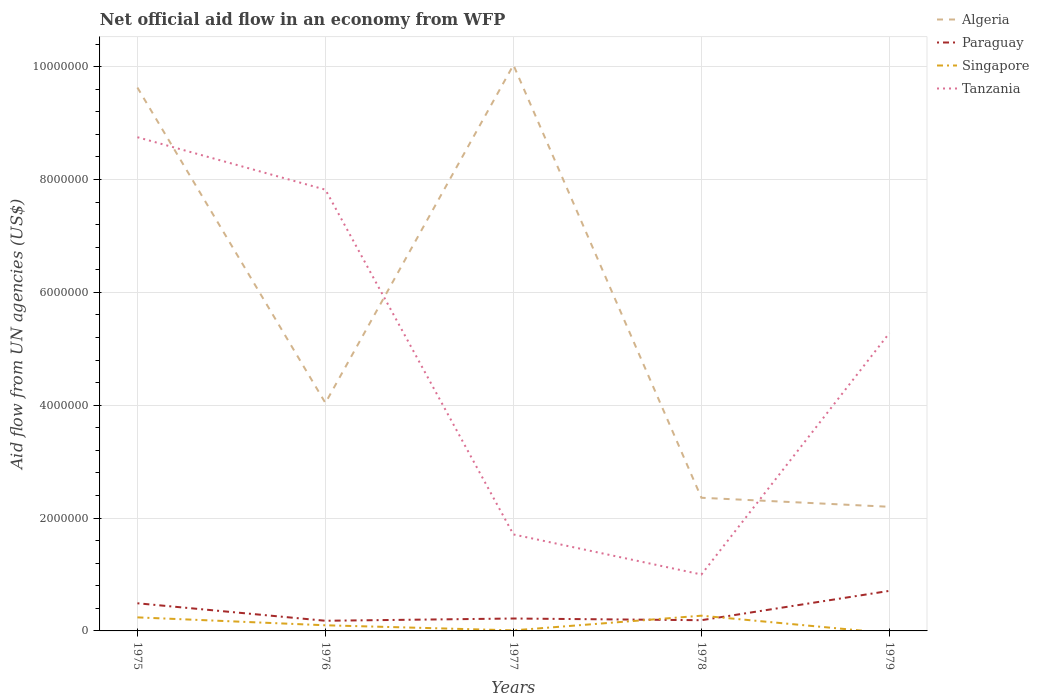How many different coloured lines are there?
Your response must be concise. 4. Does the line corresponding to Tanzania intersect with the line corresponding to Singapore?
Make the answer very short. No. Across all years, what is the maximum net official aid flow in Paraguay?
Offer a very short reply. 1.80e+05. What is the total net official aid flow in Singapore in the graph?
Give a very brief answer. 1.40e+05. What is the difference between the highest and the second highest net official aid flow in Tanzania?
Keep it short and to the point. 7.75e+06. How many years are there in the graph?
Offer a very short reply. 5. Are the values on the major ticks of Y-axis written in scientific E-notation?
Provide a succinct answer. No. Does the graph contain any zero values?
Provide a short and direct response. Yes. Does the graph contain grids?
Ensure brevity in your answer.  Yes. Where does the legend appear in the graph?
Provide a short and direct response. Top right. How many legend labels are there?
Offer a terse response. 4. What is the title of the graph?
Your answer should be very brief. Net official aid flow in an economy from WFP. What is the label or title of the X-axis?
Provide a short and direct response. Years. What is the label or title of the Y-axis?
Provide a succinct answer. Aid flow from UN agencies (US$). What is the Aid flow from UN agencies (US$) of Algeria in 1975?
Your answer should be very brief. 9.63e+06. What is the Aid flow from UN agencies (US$) in Paraguay in 1975?
Offer a very short reply. 4.90e+05. What is the Aid flow from UN agencies (US$) of Singapore in 1975?
Keep it short and to the point. 2.40e+05. What is the Aid flow from UN agencies (US$) in Tanzania in 1975?
Give a very brief answer. 8.75e+06. What is the Aid flow from UN agencies (US$) in Algeria in 1976?
Your answer should be very brief. 4.04e+06. What is the Aid flow from UN agencies (US$) in Paraguay in 1976?
Offer a very short reply. 1.80e+05. What is the Aid flow from UN agencies (US$) of Singapore in 1976?
Provide a succinct answer. 1.00e+05. What is the Aid flow from UN agencies (US$) of Tanzania in 1976?
Your answer should be compact. 7.82e+06. What is the Aid flow from UN agencies (US$) of Algeria in 1977?
Offer a very short reply. 1.00e+07. What is the Aid flow from UN agencies (US$) of Paraguay in 1977?
Provide a short and direct response. 2.20e+05. What is the Aid flow from UN agencies (US$) in Tanzania in 1977?
Keep it short and to the point. 1.71e+06. What is the Aid flow from UN agencies (US$) in Algeria in 1978?
Your answer should be compact. 2.36e+06. What is the Aid flow from UN agencies (US$) of Paraguay in 1978?
Ensure brevity in your answer.  1.90e+05. What is the Aid flow from UN agencies (US$) in Singapore in 1978?
Your response must be concise. 2.70e+05. What is the Aid flow from UN agencies (US$) of Algeria in 1979?
Your answer should be very brief. 2.20e+06. What is the Aid flow from UN agencies (US$) of Paraguay in 1979?
Your response must be concise. 7.10e+05. What is the Aid flow from UN agencies (US$) in Tanzania in 1979?
Keep it short and to the point. 5.28e+06. Across all years, what is the maximum Aid flow from UN agencies (US$) in Algeria?
Give a very brief answer. 1.00e+07. Across all years, what is the maximum Aid flow from UN agencies (US$) in Paraguay?
Provide a succinct answer. 7.10e+05. Across all years, what is the maximum Aid flow from UN agencies (US$) of Singapore?
Your answer should be compact. 2.70e+05. Across all years, what is the maximum Aid flow from UN agencies (US$) of Tanzania?
Give a very brief answer. 8.75e+06. Across all years, what is the minimum Aid flow from UN agencies (US$) in Algeria?
Keep it short and to the point. 2.20e+06. Across all years, what is the minimum Aid flow from UN agencies (US$) of Paraguay?
Offer a very short reply. 1.80e+05. What is the total Aid flow from UN agencies (US$) of Algeria in the graph?
Make the answer very short. 2.83e+07. What is the total Aid flow from UN agencies (US$) in Paraguay in the graph?
Make the answer very short. 1.79e+06. What is the total Aid flow from UN agencies (US$) of Singapore in the graph?
Keep it short and to the point. 6.20e+05. What is the total Aid flow from UN agencies (US$) of Tanzania in the graph?
Give a very brief answer. 2.46e+07. What is the difference between the Aid flow from UN agencies (US$) of Algeria in 1975 and that in 1976?
Keep it short and to the point. 5.59e+06. What is the difference between the Aid flow from UN agencies (US$) of Singapore in 1975 and that in 1976?
Keep it short and to the point. 1.40e+05. What is the difference between the Aid flow from UN agencies (US$) of Tanzania in 1975 and that in 1976?
Provide a succinct answer. 9.30e+05. What is the difference between the Aid flow from UN agencies (US$) of Algeria in 1975 and that in 1977?
Offer a terse response. -4.00e+05. What is the difference between the Aid flow from UN agencies (US$) in Paraguay in 1975 and that in 1977?
Your answer should be very brief. 2.70e+05. What is the difference between the Aid flow from UN agencies (US$) of Tanzania in 1975 and that in 1977?
Make the answer very short. 7.04e+06. What is the difference between the Aid flow from UN agencies (US$) of Algeria in 1975 and that in 1978?
Your answer should be compact. 7.27e+06. What is the difference between the Aid flow from UN agencies (US$) of Singapore in 1975 and that in 1978?
Give a very brief answer. -3.00e+04. What is the difference between the Aid flow from UN agencies (US$) in Tanzania in 1975 and that in 1978?
Your answer should be compact. 7.75e+06. What is the difference between the Aid flow from UN agencies (US$) of Algeria in 1975 and that in 1979?
Offer a terse response. 7.43e+06. What is the difference between the Aid flow from UN agencies (US$) of Paraguay in 1975 and that in 1979?
Your response must be concise. -2.20e+05. What is the difference between the Aid flow from UN agencies (US$) in Tanzania in 1975 and that in 1979?
Your answer should be compact. 3.47e+06. What is the difference between the Aid flow from UN agencies (US$) of Algeria in 1976 and that in 1977?
Keep it short and to the point. -5.99e+06. What is the difference between the Aid flow from UN agencies (US$) in Paraguay in 1976 and that in 1977?
Keep it short and to the point. -4.00e+04. What is the difference between the Aid flow from UN agencies (US$) of Tanzania in 1976 and that in 1977?
Keep it short and to the point. 6.11e+06. What is the difference between the Aid flow from UN agencies (US$) in Algeria in 1976 and that in 1978?
Offer a terse response. 1.68e+06. What is the difference between the Aid flow from UN agencies (US$) in Paraguay in 1976 and that in 1978?
Give a very brief answer. -10000. What is the difference between the Aid flow from UN agencies (US$) in Tanzania in 1976 and that in 1978?
Your answer should be compact. 6.82e+06. What is the difference between the Aid flow from UN agencies (US$) in Algeria in 1976 and that in 1979?
Your answer should be compact. 1.84e+06. What is the difference between the Aid flow from UN agencies (US$) of Paraguay in 1976 and that in 1979?
Provide a succinct answer. -5.30e+05. What is the difference between the Aid flow from UN agencies (US$) of Tanzania in 1976 and that in 1979?
Offer a very short reply. 2.54e+06. What is the difference between the Aid flow from UN agencies (US$) of Algeria in 1977 and that in 1978?
Offer a terse response. 7.67e+06. What is the difference between the Aid flow from UN agencies (US$) in Paraguay in 1977 and that in 1978?
Offer a very short reply. 3.00e+04. What is the difference between the Aid flow from UN agencies (US$) of Tanzania in 1977 and that in 1978?
Offer a terse response. 7.10e+05. What is the difference between the Aid flow from UN agencies (US$) of Algeria in 1977 and that in 1979?
Your answer should be compact. 7.83e+06. What is the difference between the Aid flow from UN agencies (US$) of Paraguay in 1977 and that in 1979?
Your answer should be compact. -4.90e+05. What is the difference between the Aid flow from UN agencies (US$) in Tanzania in 1977 and that in 1979?
Provide a short and direct response. -3.57e+06. What is the difference between the Aid flow from UN agencies (US$) in Paraguay in 1978 and that in 1979?
Give a very brief answer. -5.20e+05. What is the difference between the Aid flow from UN agencies (US$) in Tanzania in 1978 and that in 1979?
Offer a very short reply. -4.28e+06. What is the difference between the Aid flow from UN agencies (US$) in Algeria in 1975 and the Aid flow from UN agencies (US$) in Paraguay in 1976?
Give a very brief answer. 9.45e+06. What is the difference between the Aid flow from UN agencies (US$) in Algeria in 1975 and the Aid flow from UN agencies (US$) in Singapore in 1976?
Keep it short and to the point. 9.53e+06. What is the difference between the Aid flow from UN agencies (US$) in Algeria in 1975 and the Aid flow from UN agencies (US$) in Tanzania in 1976?
Offer a very short reply. 1.81e+06. What is the difference between the Aid flow from UN agencies (US$) in Paraguay in 1975 and the Aid flow from UN agencies (US$) in Singapore in 1976?
Your answer should be compact. 3.90e+05. What is the difference between the Aid flow from UN agencies (US$) of Paraguay in 1975 and the Aid flow from UN agencies (US$) of Tanzania in 1976?
Ensure brevity in your answer.  -7.33e+06. What is the difference between the Aid flow from UN agencies (US$) of Singapore in 1975 and the Aid flow from UN agencies (US$) of Tanzania in 1976?
Your answer should be very brief. -7.58e+06. What is the difference between the Aid flow from UN agencies (US$) of Algeria in 1975 and the Aid flow from UN agencies (US$) of Paraguay in 1977?
Ensure brevity in your answer.  9.41e+06. What is the difference between the Aid flow from UN agencies (US$) of Algeria in 1975 and the Aid flow from UN agencies (US$) of Singapore in 1977?
Keep it short and to the point. 9.62e+06. What is the difference between the Aid flow from UN agencies (US$) of Algeria in 1975 and the Aid flow from UN agencies (US$) of Tanzania in 1977?
Make the answer very short. 7.92e+06. What is the difference between the Aid flow from UN agencies (US$) in Paraguay in 1975 and the Aid flow from UN agencies (US$) in Singapore in 1977?
Your response must be concise. 4.80e+05. What is the difference between the Aid flow from UN agencies (US$) in Paraguay in 1975 and the Aid flow from UN agencies (US$) in Tanzania in 1977?
Provide a succinct answer. -1.22e+06. What is the difference between the Aid flow from UN agencies (US$) of Singapore in 1975 and the Aid flow from UN agencies (US$) of Tanzania in 1977?
Provide a succinct answer. -1.47e+06. What is the difference between the Aid flow from UN agencies (US$) of Algeria in 1975 and the Aid flow from UN agencies (US$) of Paraguay in 1978?
Give a very brief answer. 9.44e+06. What is the difference between the Aid flow from UN agencies (US$) in Algeria in 1975 and the Aid flow from UN agencies (US$) in Singapore in 1978?
Your answer should be compact. 9.36e+06. What is the difference between the Aid flow from UN agencies (US$) in Algeria in 1975 and the Aid flow from UN agencies (US$) in Tanzania in 1978?
Your response must be concise. 8.63e+06. What is the difference between the Aid flow from UN agencies (US$) of Paraguay in 1975 and the Aid flow from UN agencies (US$) of Singapore in 1978?
Offer a terse response. 2.20e+05. What is the difference between the Aid flow from UN agencies (US$) in Paraguay in 1975 and the Aid flow from UN agencies (US$) in Tanzania in 1978?
Provide a succinct answer. -5.10e+05. What is the difference between the Aid flow from UN agencies (US$) of Singapore in 1975 and the Aid flow from UN agencies (US$) of Tanzania in 1978?
Provide a short and direct response. -7.60e+05. What is the difference between the Aid flow from UN agencies (US$) of Algeria in 1975 and the Aid flow from UN agencies (US$) of Paraguay in 1979?
Your answer should be very brief. 8.92e+06. What is the difference between the Aid flow from UN agencies (US$) of Algeria in 1975 and the Aid flow from UN agencies (US$) of Tanzania in 1979?
Give a very brief answer. 4.35e+06. What is the difference between the Aid flow from UN agencies (US$) of Paraguay in 1975 and the Aid flow from UN agencies (US$) of Tanzania in 1979?
Your response must be concise. -4.79e+06. What is the difference between the Aid flow from UN agencies (US$) in Singapore in 1975 and the Aid flow from UN agencies (US$) in Tanzania in 1979?
Ensure brevity in your answer.  -5.04e+06. What is the difference between the Aid flow from UN agencies (US$) in Algeria in 1976 and the Aid flow from UN agencies (US$) in Paraguay in 1977?
Provide a succinct answer. 3.82e+06. What is the difference between the Aid flow from UN agencies (US$) in Algeria in 1976 and the Aid flow from UN agencies (US$) in Singapore in 1977?
Your answer should be very brief. 4.03e+06. What is the difference between the Aid flow from UN agencies (US$) in Algeria in 1976 and the Aid flow from UN agencies (US$) in Tanzania in 1977?
Make the answer very short. 2.33e+06. What is the difference between the Aid flow from UN agencies (US$) in Paraguay in 1976 and the Aid flow from UN agencies (US$) in Tanzania in 1977?
Your answer should be compact. -1.53e+06. What is the difference between the Aid flow from UN agencies (US$) of Singapore in 1976 and the Aid flow from UN agencies (US$) of Tanzania in 1977?
Provide a short and direct response. -1.61e+06. What is the difference between the Aid flow from UN agencies (US$) in Algeria in 1976 and the Aid flow from UN agencies (US$) in Paraguay in 1978?
Keep it short and to the point. 3.85e+06. What is the difference between the Aid flow from UN agencies (US$) of Algeria in 1976 and the Aid flow from UN agencies (US$) of Singapore in 1978?
Your response must be concise. 3.77e+06. What is the difference between the Aid flow from UN agencies (US$) of Algeria in 1976 and the Aid flow from UN agencies (US$) of Tanzania in 1978?
Keep it short and to the point. 3.04e+06. What is the difference between the Aid flow from UN agencies (US$) of Paraguay in 1976 and the Aid flow from UN agencies (US$) of Singapore in 1978?
Offer a terse response. -9.00e+04. What is the difference between the Aid flow from UN agencies (US$) of Paraguay in 1976 and the Aid flow from UN agencies (US$) of Tanzania in 1978?
Offer a very short reply. -8.20e+05. What is the difference between the Aid flow from UN agencies (US$) of Singapore in 1976 and the Aid flow from UN agencies (US$) of Tanzania in 1978?
Your answer should be very brief. -9.00e+05. What is the difference between the Aid flow from UN agencies (US$) in Algeria in 1976 and the Aid flow from UN agencies (US$) in Paraguay in 1979?
Your answer should be very brief. 3.33e+06. What is the difference between the Aid flow from UN agencies (US$) in Algeria in 1976 and the Aid flow from UN agencies (US$) in Tanzania in 1979?
Provide a short and direct response. -1.24e+06. What is the difference between the Aid flow from UN agencies (US$) in Paraguay in 1976 and the Aid flow from UN agencies (US$) in Tanzania in 1979?
Give a very brief answer. -5.10e+06. What is the difference between the Aid flow from UN agencies (US$) of Singapore in 1976 and the Aid flow from UN agencies (US$) of Tanzania in 1979?
Offer a terse response. -5.18e+06. What is the difference between the Aid flow from UN agencies (US$) in Algeria in 1977 and the Aid flow from UN agencies (US$) in Paraguay in 1978?
Offer a very short reply. 9.84e+06. What is the difference between the Aid flow from UN agencies (US$) in Algeria in 1977 and the Aid flow from UN agencies (US$) in Singapore in 1978?
Your answer should be very brief. 9.76e+06. What is the difference between the Aid flow from UN agencies (US$) in Algeria in 1977 and the Aid flow from UN agencies (US$) in Tanzania in 1978?
Give a very brief answer. 9.03e+06. What is the difference between the Aid flow from UN agencies (US$) in Paraguay in 1977 and the Aid flow from UN agencies (US$) in Singapore in 1978?
Your response must be concise. -5.00e+04. What is the difference between the Aid flow from UN agencies (US$) of Paraguay in 1977 and the Aid flow from UN agencies (US$) of Tanzania in 1978?
Your answer should be compact. -7.80e+05. What is the difference between the Aid flow from UN agencies (US$) of Singapore in 1977 and the Aid flow from UN agencies (US$) of Tanzania in 1978?
Provide a short and direct response. -9.90e+05. What is the difference between the Aid flow from UN agencies (US$) in Algeria in 1977 and the Aid flow from UN agencies (US$) in Paraguay in 1979?
Give a very brief answer. 9.32e+06. What is the difference between the Aid flow from UN agencies (US$) of Algeria in 1977 and the Aid flow from UN agencies (US$) of Tanzania in 1979?
Keep it short and to the point. 4.75e+06. What is the difference between the Aid flow from UN agencies (US$) of Paraguay in 1977 and the Aid flow from UN agencies (US$) of Tanzania in 1979?
Provide a short and direct response. -5.06e+06. What is the difference between the Aid flow from UN agencies (US$) in Singapore in 1977 and the Aid flow from UN agencies (US$) in Tanzania in 1979?
Ensure brevity in your answer.  -5.27e+06. What is the difference between the Aid flow from UN agencies (US$) of Algeria in 1978 and the Aid flow from UN agencies (US$) of Paraguay in 1979?
Offer a very short reply. 1.65e+06. What is the difference between the Aid flow from UN agencies (US$) in Algeria in 1978 and the Aid flow from UN agencies (US$) in Tanzania in 1979?
Ensure brevity in your answer.  -2.92e+06. What is the difference between the Aid flow from UN agencies (US$) of Paraguay in 1978 and the Aid flow from UN agencies (US$) of Tanzania in 1979?
Offer a terse response. -5.09e+06. What is the difference between the Aid flow from UN agencies (US$) in Singapore in 1978 and the Aid flow from UN agencies (US$) in Tanzania in 1979?
Offer a terse response. -5.01e+06. What is the average Aid flow from UN agencies (US$) of Algeria per year?
Ensure brevity in your answer.  5.65e+06. What is the average Aid flow from UN agencies (US$) of Paraguay per year?
Your answer should be compact. 3.58e+05. What is the average Aid flow from UN agencies (US$) of Singapore per year?
Provide a succinct answer. 1.24e+05. What is the average Aid flow from UN agencies (US$) in Tanzania per year?
Your answer should be very brief. 4.91e+06. In the year 1975, what is the difference between the Aid flow from UN agencies (US$) in Algeria and Aid flow from UN agencies (US$) in Paraguay?
Make the answer very short. 9.14e+06. In the year 1975, what is the difference between the Aid flow from UN agencies (US$) in Algeria and Aid flow from UN agencies (US$) in Singapore?
Provide a succinct answer. 9.39e+06. In the year 1975, what is the difference between the Aid flow from UN agencies (US$) in Algeria and Aid flow from UN agencies (US$) in Tanzania?
Keep it short and to the point. 8.80e+05. In the year 1975, what is the difference between the Aid flow from UN agencies (US$) in Paraguay and Aid flow from UN agencies (US$) in Tanzania?
Your response must be concise. -8.26e+06. In the year 1975, what is the difference between the Aid flow from UN agencies (US$) of Singapore and Aid flow from UN agencies (US$) of Tanzania?
Make the answer very short. -8.51e+06. In the year 1976, what is the difference between the Aid flow from UN agencies (US$) of Algeria and Aid flow from UN agencies (US$) of Paraguay?
Give a very brief answer. 3.86e+06. In the year 1976, what is the difference between the Aid flow from UN agencies (US$) of Algeria and Aid flow from UN agencies (US$) of Singapore?
Ensure brevity in your answer.  3.94e+06. In the year 1976, what is the difference between the Aid flow from UN agencies (US$) in Algeria and Aid flow from UN agencies (US$) in Tanzania?
Give a very brief answer. -3.78e+06. In the year 1976, what is the difference between the Aid flow from UN agencies (US$) in Paraguay and Aid flow from UN agencies (US$) in Singapore?
Make the answer very short. 8.00e+04. In the year 1976, what is the difference between the Aid flow from UN agencies (US$) in Paraguay and Aid flow from UN agencies (US$) in Tanzania?
Your answer should be very brief. -7.64e+06. In the year 1976, what is the difference between the Aid flow from UN agencies (US$) in Singapore and Aid flow from UN agencies (US$) in Tanzania?
Provide a short and direct response. -7.72e+06. In the year 1977, what is the difference between the Aid flow from UN agencies (US$) in Algeria and Aid flow from UN agencies (US$) in Paraguay?
Provide a short and direct response. 9.81e+06. In the year 1977, what is the difference between the Aid flow from UN agencies (US$) of Algeria and Aid flow from UN agencies (US$) of Singapore?
Ensure brevity in your answer.  1.00e+07. In the year 1977, what is the difference between the Aid flow from UN agencies (US$) in Algeria and Aid flow from UN agencies (US$) in Tanzania?
Your answer should be very brief. 8.32e+06. In the year 1977, what is the difference between the Aid flow from UN agencies (US$) in Paraguay and Aid flow from UN agencies (US$) in Tanzania?
Offer a terse response. -1.49e+06. In the year 1977, what is the difference between the Aid flow from UN agencies (US$) of Singapore and Aid flow from UN agencies (US$) of Tanzania?
Your answer should be compact. -1.70e+06. In the year 1978, what is the difference between the Aid flow from UN agencies (US$) in Algeria and Aid flow from UN agencies (US$) in Paraguay?
Offer a very short reply. 2.17e+06. In the year 1978, what is the difference between the Aid flow from UN agencies (US$) in Algeria and Aid flow from UN agencies (US$) in Singapore?
Offer a very short reply. 2.09e+06. In the year 1978, what is the difference between the Aid flow from UN agencies (US$) of Algeria and Aid flow from UN agencies (US$) of Tanzania?
Provide a short and direct response. 1.36e+06. In the year 1978, what is the difference between the Aid flow from UN agencies (US$) in Paraguay and Aid flow from UN agencies (US$) in Singapore?
Ensure brevity in your answer.  -8.00e+04. In the year 1978, what is the difference between the Aid flow from UN agencies (US$) in Paraguay and Aid flow from UN agencies (US$) in Tanzania?
Your response must be concise. -8.10e+05. In the year 1978, what is the difference between the Aid flow from UN agencies (US$) of Singapore and Aid flow from UN agencies (US$) of Tanzania?
Provide a short and direct response. -7.30e+05. In the year 1979, what is the difference between the Aid flow from UN agencies (US$) in Algeria and Aid flow from UN agencies (US$) in Paraguay?
Offer a very short reply. 1.49e+06. In the year 1979, what is the difference between the Aid flow from UN agencies (US$) of Algeria and Aid flow from UN agencies (US$) of Tanzania?
Make the answer very short. -3.08e+06. In the year 1979, what is the difference between the Aid flow from UN agencies (US$) of Paraguay and Aid flow from UN agencies (US$) of Tanzania?
Provide a succinct answer. -4.57e+06. What is the ratio of the Aid flow from UN agencies (US$) in Algeria in 1975 to that in 1976?
Ensure brevity in your answer.  2.38. What is the ratio of the Aid flow from UN agencies (US$) in Paraguay in 1975 to that in 1976?
Keep it short and to the point. 2.72. What is the ratio of the Aid flow from UN agencies (US$) of Tanzania in 1975 to that in 1976?
Ensure brevity in your answer.  1.12. What is the ratio of the Aid flow from UN agencies (US$) in Algeria in 1975 to that in 1977?
Give a very brief answer. 0.96. What is the ratio of the Aid flow from UN agencies (US$) in Paraguay in 1975 to that in 1977?
Keep it short and to the point. 2.23. What is the ratio of the Aid flow from UN agencies (US$) in Tanzania in 1975 to that in 1977?
Offer a terse response. 5.12. What is the ratio of the Aid flow from UN agencies (US$) in Algeria in 1975 to that in 1978?
Your answer should be very brief. 4.08. What is the ratio of the Aid flow from UN agencies (US$) of Paraguay in 1975 to that in 1978?
Provide a short and direct response. 2.58. What is the ratio of the Aid flow from UN agencies (US$) of Tanzania in 1975 to that in 1978?
Provide a short and direct response. 8.75. What is the ratio of the Aid flow from UN agencies (US$) in Algeria in 1975 to that in 1979?
Your response must be concise. 4.38. What is the ratio of the Aid flow from UN agencies (US$) in Paraguay in 1975 to that in 1979?
Keep it short and to the point. 0.69. What is the ratio of the Aid flow from UN agencies (US$) in Tanzania in 1975 to that in 1979?
Offer a terse response. 1.66. What is the ratio of the Aid flow from UN agencies (US$) of Algeria in 1976 to that in 1977?
Provide a short and direct response. 0.4. What is the ratio of the Aid flow from UN agencies (US$) in Paraguay in 1976 to that in 1977?
Your answer should be very brief. 0.82. What is the ratio of the Aid flow from UN agencies (US$) in Singapore in 1976 to that in 1977?
Your answer should be compact. 10. What is the ratio of the Aid flow from UN agencies (US$) of Tanzania in 1976 to that in 1977?
Ensure brevity in your answer.  4.57. What is the ratio of the Aid flow from UN agencies (US$) of Algeria in 1976 to that in 1978?
Make the answer very short. 1.71. What is the ratio of the Aid flow from UN agencies (US$) of Paraguay in 1976 to that in 1978?
Provide a short and direct response. 0.95. What is the ratio of the Aid flow from UN agencies (US$) in Singapore in 1976 to that in 1978?
Your answer should be compact. 0.37. What is the ratio of the Aid flow from UN agencies (US$) in Tanzania in 1976 to that in 1978?
Your response must be concise. 7.82. What is the ratio of the Aid flow from UN agencies (US$) in Algeria in 1976 to that in 1979?
Ensure brevity in your answer.  1.84. What is the ratio of the Aid flow from UN agencies (US$) in Paraguay in 1976 to that in 1979?
Give a very brief answer. 0.25. What is the ratio of the Aid flow from UN agencies (US$) of Tanzania in 1976 to that in 1979?
Offer a terse response. 1.48. What is the ratio of the Aid flow from UN agencies (US$) of Algeria in 1977 to that in 1978?
Offer a terse response. 4.25. What is the ratio of the Aid flow from UN agencies (US$) of Paraguay in 1977 to that in 1978?
Your answer should be very brief. 1.16. What is the ratio of the Aid flow from UN agencies (US$) of Singapore in 1977 to that in 1978?
Ensure brevity in your answer.  0.04. What is the ratio of the Aid flow from UN agencies (US$) of Tanzania in 1977 to that in 1978?
Make the answer very short. 1.71. What is the ratio of the Aid flow from UN agencies (US$) of Algeria in 1977 to that in 1979?
Offer a terse response. 4.56. What is the ratio of the Aid flow from UN agencies (US$) of Paraguay in 1977 to that in 1979?
Your answer should be very brief. 0.31. What is the ratio of the Aid flow from UN agencies (US$) of Tanzania in 1977 to that in 1979?
Provide a short and direct response. 0.32. What is the ratio of the Aid flow from UN agencies (US$) in Algeria in 1978 to that in 1979?
Make the answer very short. 1.07. What is the ratio of the Aid flow from UN agencies (US$) of Paraguay in 1978 to that in 1979?
Offer a terse response. 0.27. What is the ratio of the Aid flow from UN agencies (US$) in Tanzania in 1978 to that in 1979?
Provide a short and direct response. 0.19. What is the difference between the highest and the second highest Aid flow from UN agencies (US$) in Algeria?
Give a very brief answer. 4.00e+05. What is the difference between the highest and the second highest Aid flow from UN agencies (US$) in Singapore?
Ensure brevity in your answer.  3.00e+04. What is the difference between the highest and the second highest Aid flow from UN agencies (US$) in Tanzania?
Provide a short and direct response. 9.30e+05. What is the difference between the highest and the lowest Aid flow from UN agencies (US$) of Algeria?
Your response must be concise. 7.83e+06. What is the difference between the highest and the lowest Aid flow from UN agencies (US$) in Paraguay?
Provide a short and direct response. 5.30e+05. What is the difference between the highest and the lowest Aid flow from UN agencies (US$) in Tanzania?
Provide a short and direct response. 7.75e+06. 